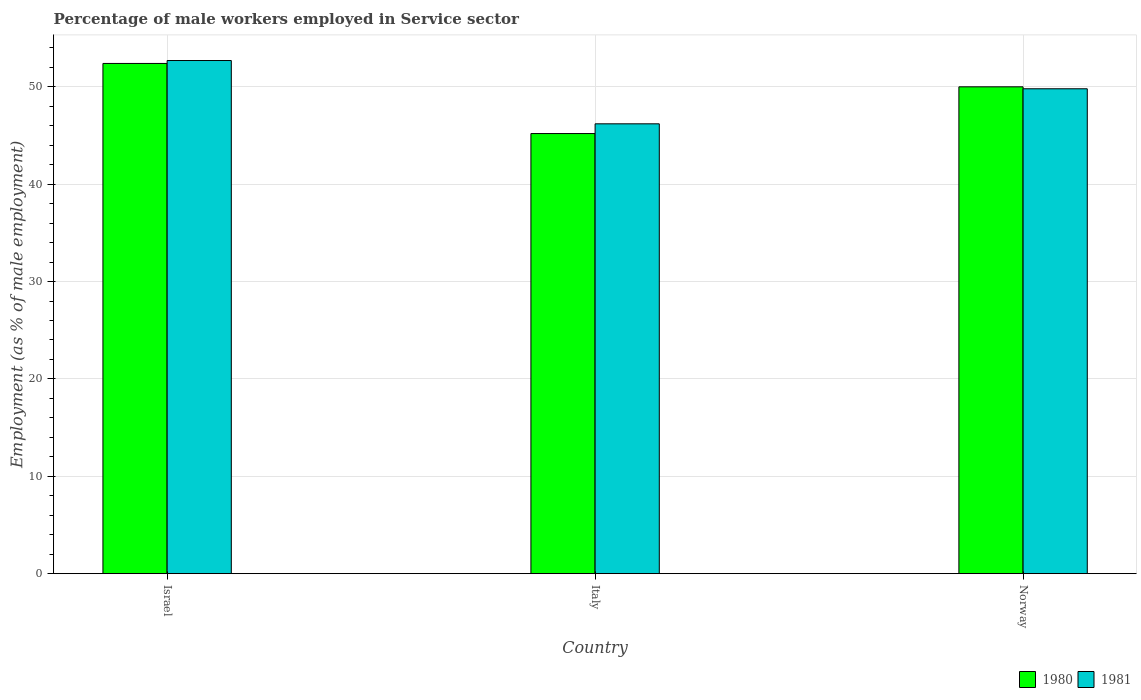How many groups of bars are there?
Provide a short and direct response. 3. Are the number of bars per tick equal to the number of legend labels?
Give a very brief answer. Yes. How many bars are there on the 3rd tick from the left?
Your answer should be compact. 2. How many bars are there on the 1st tick from the right?
Ensure brevity in your answer.  2. What is the label of the 3rd group of bars from the left?
Your answer should be compact. Norway. In how many cases, is the number of bars for a given country not equal to the number of legend labels?
Offer a terse response. 0. What is the percentage of male workers employed in Service sector in 1981 in Italy?
Ensure brevity in your answer.  46.2. Across all countries, what is the maximum percentage of male workers employed in Service sector in 1980?
Ensure brevity in your answer.  52.4. Across all countries, what is the minimum percentage of male workers employed in Service sector in 1980?
Your response must be concise. 45.2. What is the total percentage of male workers employed in Service sector in 1981 in the graph?
Ensure brevity in your answer.  148.7. What is the difference between the percentage of male workers employed in Service sector in 1980 in Israel and that in Norway?
Offer a very short reply. 2.4. What is the difference between the percentage of male workers employed in Service sector in 1981 in Norway and the percentage of male workers employed in Service sector in 1980 in Italy?
Make the answer very short. 4.6. What is the average percentage of male workers employed in Service sector in 1980 per country?
Offer a very short reply. 49.2. What is the ratio of the percentage of male workers employed in Service sector in 1980 in Italy to that in Norway?
Give a very brief answer. 0.9. Is the difference between the percentage of male workers employed in Service sector in 1981 in Israel and Norway greater than the difference between the percentage of male workers employed in Service sector in 1980 in Israel and Norway?
Provide a short and direct response. Yes. What is the difference between the highest and the second highest percentage of male workers employed in Service sector in 1981?
Your answer should be very brief. -2.9. What is the difference between the highest and the lowest percentage of male workers employed in Service sector in 1980?
Give a very brief answer. 7.2. In how many countries, is the percentage of male workers employed in Service sector in 1980 greater than the average percentage of male workers employed in Service sector in 1980 taken over all countries?
Provide a short and direct response. 2. Is the sum of the percentage of male workers employed in Service sector in 1981 in Italy and Norway greater than the maximum percentage of male workers employed in Service sector in 1980 across all countries?
Keep it short and to the point. Yes. What does the 2nd bar from the right in Italy represents?
Offer a very short reply. 1980. Are all the bars in the graph horizontal?
Provide a short and direct response. No. How many countries are there in the graph?
Keep it short and to the point. 3. What is the difference between two consecutive major ticks on the Y-axis?
Your answer should be very brief. 10. Does the graph contain any zero values?
Your answer should be compact. No. Does the graph contain grids?
Give a very brief answer. Yes. What is the title of the graph?
Keep it short and to the point. Percentage of male workers employed in Service sector. What is the label or title of the Y-axis?
Offer a very short reply. Employment (as % of male employment). What is the Employment (as % of male employment) in 1980 in Israel?
Provide a succinct answer. 52.4. What is the Employment (as % of male employment) in 1981 in Israel?
Make the answer very short. 52.7. What is the Employment (as % of male employment) in 1980 in Italy?
Provide a succinct answer. 45.2. What is the Employment (as % of male employment) of 1981 in Italy?
Keep it short and to the point. 46.2. What is the Employment (as % of male employment) in 1980 in Norway?
Keep it short and to the point. 50. What is the Employment (as % of male employment) in 1981 in Norway?
Offer a terse response. 49.8. Across all countries, what is the maximum Employment (as % of male employment) in 1980?
Offer a very short reply. 52.4. Across all countries, what is the maximum Employment (as % of male employment) in 1981?
Make the answer very short. 52.7. Across all countries, what is the minimum Employment (as % of male employment) in 1980?
Offer a very short reply. 45.2. Across all countries, what is the minimum Employment (as % of male employment) of 1981?
Your answer should be very brief. 46.2. What is the total Employment (as % of male employment) in 1980 in the graph?
Keep it short and to the point. 147.6. What is the total Employment (as % of male employment) of 1981 in the graph?
Give a very brief answer. 148.7. What is the difference between the Employment (as % of male employment) of 1980 in Israel and that in Norway?
Your response must be concise. 2.4. What is the difference between the Employment (as % of male employment) in 1981 in Israel and that in Norway?
Give a very brief answer. 2.9. What is the difference between the Employment (as % of male employment) of 1981 in Italy and that in Norway?
Keep it short and to the point. -3.6. What is the difference between the Employment (as % of male employment) of 1980 in Israel and the Employment (as % of male employment) of 1981 in Norway?
Keep it short and to the point. 2.6. What is the difference between the Employment (as % of male employment) in 1980 in Italy and the Employment (as % of male employment) in 1981 in Norway?
Offer a terse response. -4.6. What is the average Employment (as % of male employment) of 1980 per country?
Your answer should be compact. 49.2. What is the average Employment (as % of male employment) of 1981 per country?
Make the answer very short. 49.57. What is the difference between the Employment (as % of male employment) of 1980 and Employment (as % of male employment) of 1981 in Italy?
Your answer should be very brief. -1. What is the ratio of the Employment (as % of male employment) in 1980 in Israel to that in Italy?
Provide a succinct answer. 1.16. What is the ratio of the Employment (as % of male employment) in 1981 in Israel to that in Italy?
Offer a terse response. 1.14. What is the ratio of the Employment (as % of male employment) of 1980 in Israel to that in Norway?
Ensure brevity in your answer.  1.05. What is the ratio of the Employment (as % of male employment) in 1981 in Israel to that in Norway?
Offer a very short reply. 1.06. What is the ratio of the Employment (as % of male employment) of 1980 in Italy to that in Norway?
Make the answer very short. 0.9. What is the ratio of the Employment (as % of male employment) in 1981 in Italy to that in Norway?
Provide a succinct answer. 0.93. What is the difference between the highest and the second highest Employment (as % of male employment) of 1980?
Provide a short and direct response. 2.4. What is the difference between the highest and the lowest Employment (as % of male employment) of 1980?
Give a very brief answer. 7.2. 